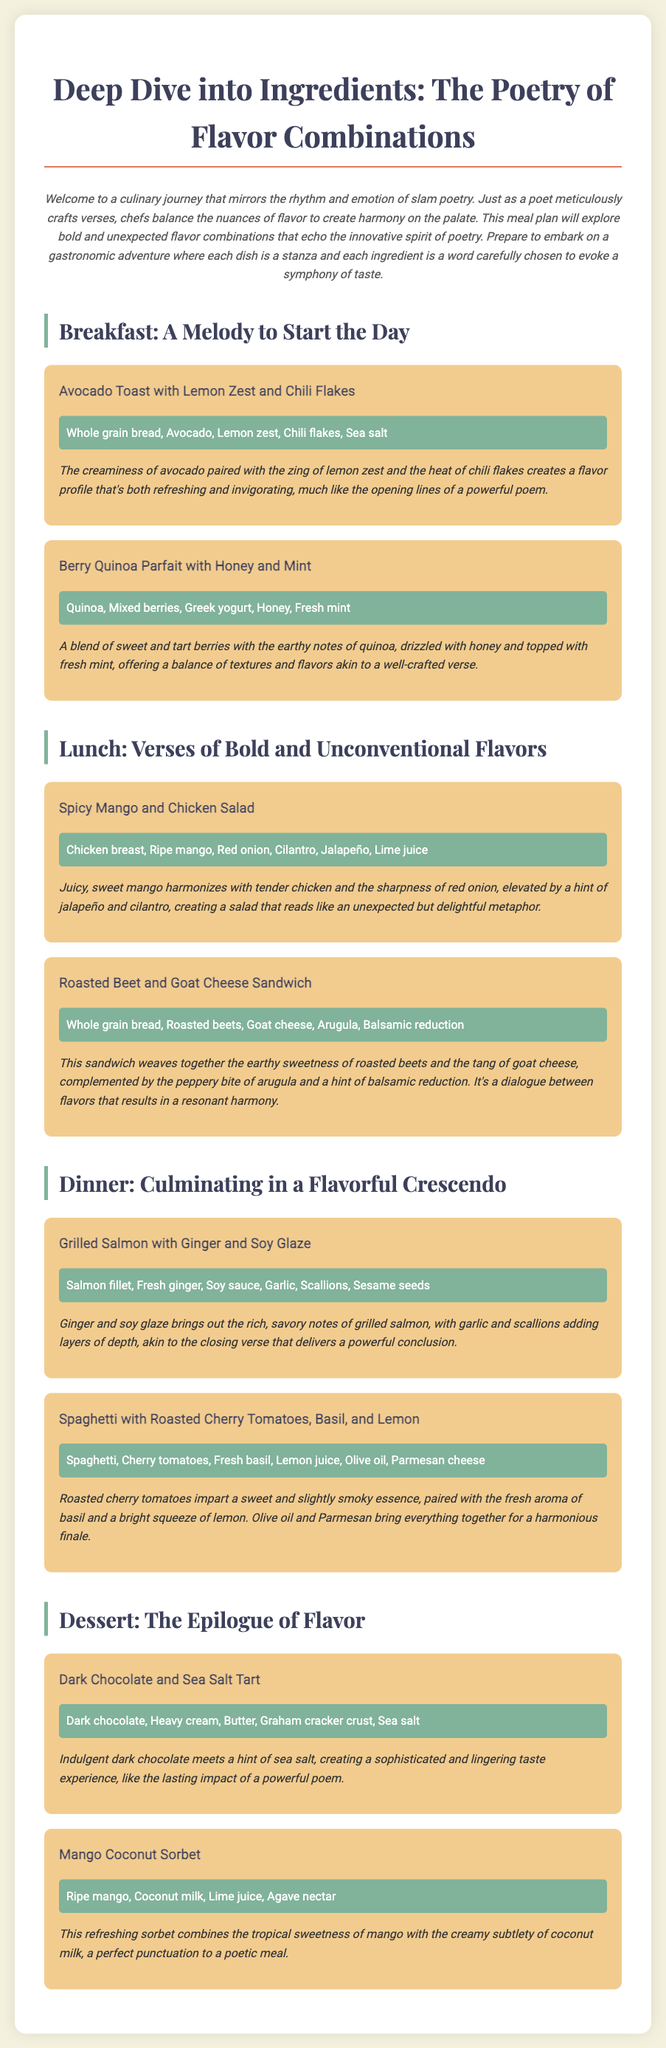what is the title of the document? The title is clearly stated at the top of the document.
Answer: Deep Dive into Ingredients: The Poetry of Flavor Combinations how many breakfast dishes are listed? The document lists two breakfast dishes in the Breakfast section.
Answer: 2 what ingredient is paired with the roasted beets in the sandwich? The description of the roasted beet and goat cheese sandwich mentions the pairing with goat cheese.
Answer: Goat cheese which dish includes a tart flavor profile? The Berry Quinoa Parfait is described with sweet and tart flavors.
Answer: Berry Quinoa Parfait what is the main protein in the Spicy Mango and Chicken Salad? The ingredients for this dish include chicken breast, which is the main protein.
Answer: Chicken breast what sweet ingredient is used in the dessert called Dark Chocolate and Sea Salt Tart? The dessert includes dark chocolate, which is a sweet ingredient.
Answer: Dark chocolate which ingredient provides a creamy texture in the Mango Coconut Sorbet? The document states coconut milk contributes to the creamy subtlety of the sorbet.
Answer: Coconut milk what flavor profile does the Grilled Salmon with Ginger and Soy Glaze highlight? The description emphasizes rich, savory notes brought out by the glaze.
Answer: Rich, savory notes 